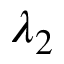<formula> <loc_0><loc_0><loc_500><loc_500>\lambda _ { 2 }</formula> 